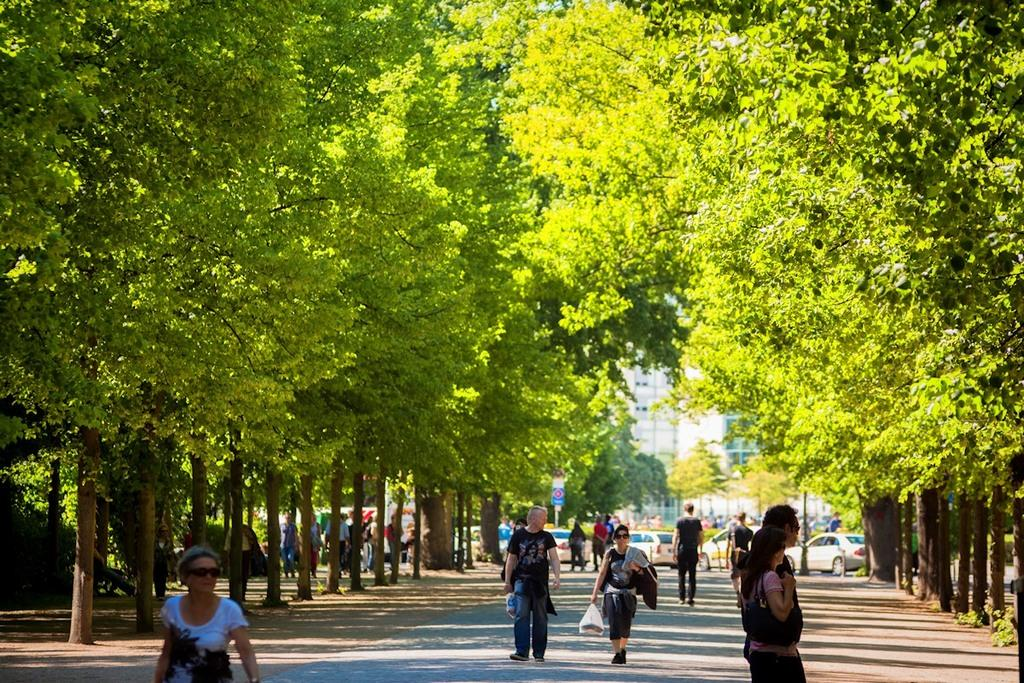What is the main feature of the image? There is a road in the image. What are the people in the image doing? Many people are walking on the road. What can be seen moving behind the road? There are vehicles moving behind the road. What type of vegetation is present on either side of the road? There are trees on either side of the road. What is the queen arguing about with the people on the road? There is no queen present in the image, nor is there any indication of an argument taking place. 